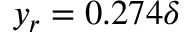Convert formula to latex. <formula><loc_0><loc_0><loc_500><loc_500>y _ { r } = 0 . 2 7 4 \delta</formula> 